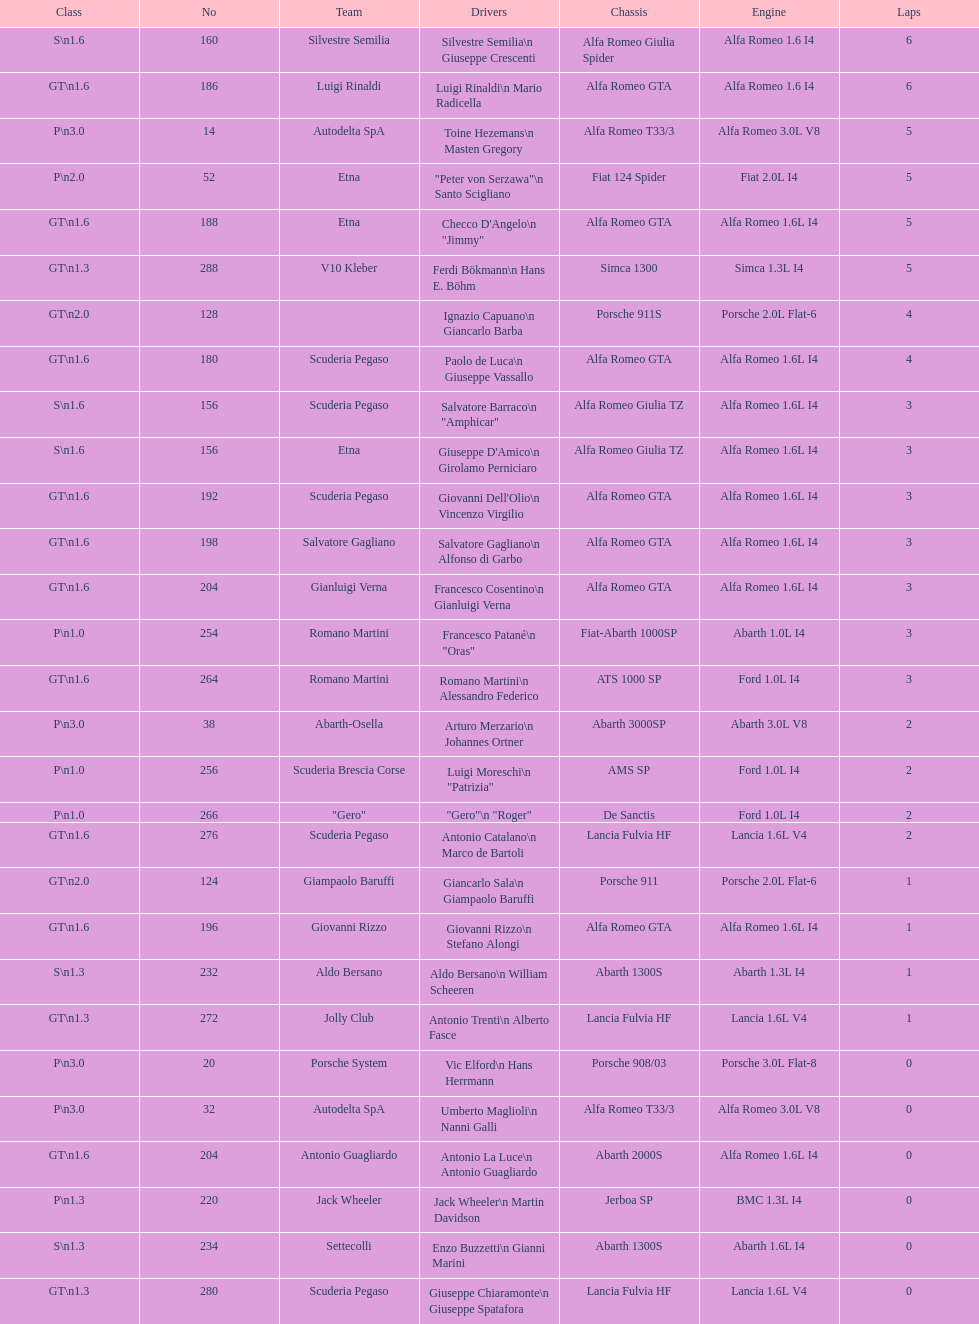Which chassis is in the middle of simca 1300 and alfa romeo gta? Porsche 911S. 